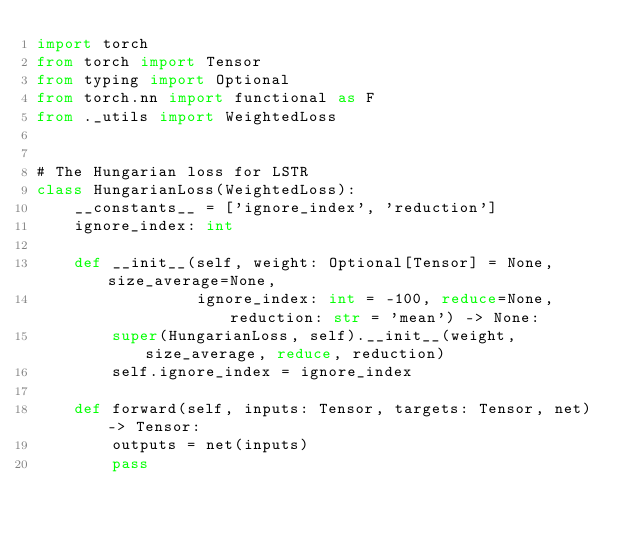Convert code to text. <code><loc_0><loc_0><loc_500><loc_500><_Python_>import torch
from torch import Tensor
from typing import Optional
from torch.nn import functional as F
from ._utils import WeightedLoss


# The Hungarian loss for LSTR
class HungarianLoss(WeightedLoss):
    __constants__ = ['ignore_index', 'reduction']
    ignore_index: int

    def __init__(self, weight: Optional[Tensor] = None, size_average=None,
                 ignore_index: int = -100, reduce=None, reduction: str = 'mean') -> None:
        super(HungarianLoss, self).__init__(weight, size_average, reduce, reduction)
        self.ignore_index = ignore_index

    def forward(self, inputs: Tensor, targets: Tensor, net) -> Tensor:
        outputs = net(inputs)
        pass
</code> 